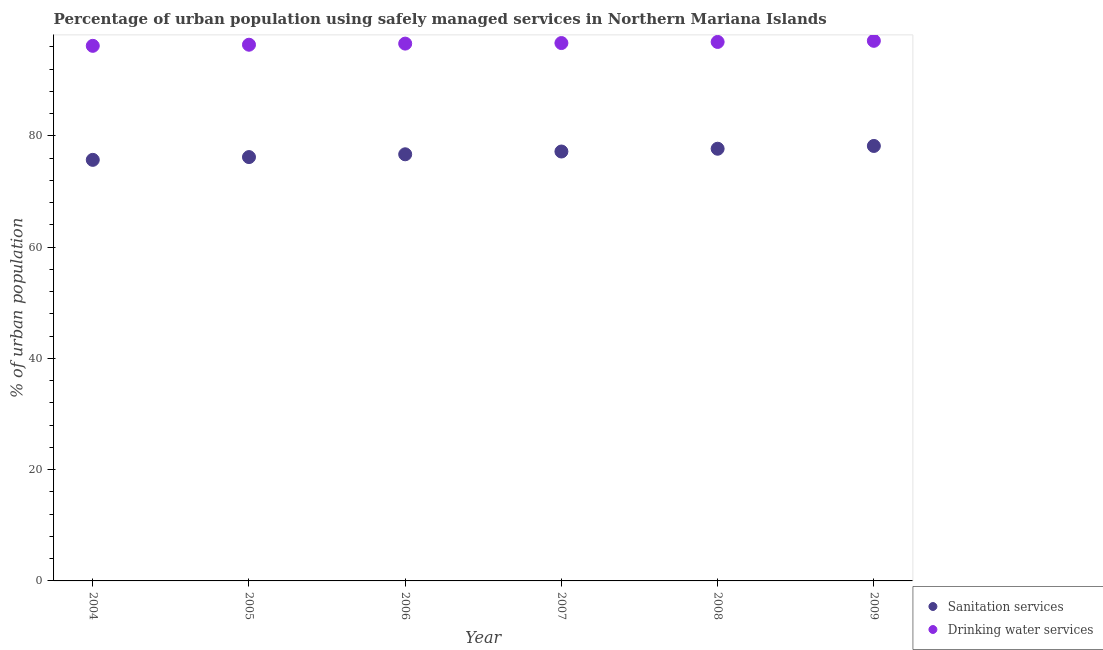What is the percentage of urban population who used sanitation services in 2009?
Offer a very short reply. 78.2. Across all years, what is the maximum percentage of urban population who used sanitation services?
Your response must be concise. 78.2. Across all years, what is the minimum percentage of urban population who used drinking water services?
Give a very brief answer. 96.2. In which year was the percentage of urban population who used sanitation services maximum?
Make the answer very short. 2009. In which year was the percentage of urban population who used drinking water services minimum?
Your answer should be very brief. 2004. What is the total percentage of urban population who used sanitation services in the graph?
Your response must be concise. 461.7. What is the average percentage of urban population who used drinking water services per year?
Provide a short and direct response. 96.65. In the year 2008, what is the difference between the percentage of urban population who used sanitation services and percentage of urban population who used drinking water services?
Provide a succinct answer. -19.2. What is the ratio of the percentage of urban population who used sanitation services in 2004 to that in 2006?
Your answer should be very brief. 0.99. What is the difference between the highest and the second highest percentage of urban population who used drinking water services?
Ensure brevity in your answer.  0.2. What is the difference between the highest and the lowest percentage of urban population who used drinking water services?
Keep it short and to the point. 0.9. Is the sum of the percentage of urban population who used drinking water services in 2005 and 2006 greater than the maximum percentage of urban population who used sanitation services across all years?
Your response must be concise. Yes. Does the percentage of urban population who used drinking water services monotonically increase over the years?
Your response must be concise. Yes. Is the percentage of urban population who used sanitation services strictly greater than the percentage of urban population who used drinking water services over the years?
Give a very brief answer. No. What is the difference between two consecutive major ticks on the Y-axis?
Provide a short and direct response. 20. Are the values on the major ticks of Y-axis written in scientific E-notation?
Provide a succinct answer. No. Does the graph contain any zero values?
Your answer should be very brief. No. Where does the legend appear in the graph?
Provide a short and direct response. Bottom right. How are the legend labels stacked?
Give a very brief answer. Vertical. What is the title of the graph?
Your response must be concise. Percentage of urban population using safely managed services in Northern Mariana Islands. What is the label or title of the X-axis?
Your response must be concise. Year. What is the label or title of the Y-axis?
Make the answer very short. % of urban population. What is the % of urban population of Sanitation services in 2004?
Make the answer very short. 75.7. What is the % of urban population of Drinking water services in 2004?
Provide a short and direct response. 96.2. What is the % of urban population of Sanitation services in 2005?
Offer a terse response. 76.2. What is the % of urban population in Drinking water services in 2005?
Keep it short and to the point. 96.4. What is the % of urban population in Sanitation services in 2006?
Your response must be concise. 76.7. What is the % of urban population of Drinking water services in 2006?
Your answer should be compact. 96.6. What is the % of urban population of Sanitation services in 2007?
Offer a terse response. 77.2. What is the % of urban population in Drinking water services in 2007?
Give a very brief answer. 96.7. What is the % of urban population of Sanitation services in 2008?
Provide a short and direct response. 77.7. What is the % of urban population in Drinking water services in 2008?
Provide a short and direct response. 96.9. What is the % of urban population of Sanitation services in 2009?
Make the answer very short. 78.2. What is the % of urban population of Drinking water services in 2009?
Provide a short and direct response. 97.1. Across all years, what is the maximum % of urban population of Sanitation services?
Provide a succinct answer. 78.2. Across all years, what is the maximum % of urban population of Drinking water services?
Your answer should be very brief. 97.1. Across all years, what is the minimum % of urban population in Sanitation services?
Keep it short and to the point. 75.7. Across all years, what is the minimum % of urban population in Drinking water services?
Your answer should be compact. 96.2. What is the total % of urban population in Sanitation services in the graph?
Ensure brevity in your answer.  461.7. What is the total % of urban population of Drinking water services in the graph?
Provide a short and direct response. 579.9. What is the difference between the % of urban population in Drinking water services in 2004 and that in 2005?
Provide a succinct answer. -0.2. What is the difference between the % of urban population in Sanitation services in 2004 and that in 2006?
Ensure brevity in your answer.  -1. What is the difference between the % of urban population of Drinking water services in 2004 and that in 2008?
Make the answer very short. -0.7. What is the difference between the % of urban population of Drinking water services in 2004 and that in 2009?
Offer a very short reply. -0.9. What is the difference between the % of urban population of Sanitation services in 2005 and that in 2006?
Provide a short and direct response. -0.5. What is the difference between the % of urban population in Drinking water services in 2005 and that in 2006?
Your answer should be very brief. -0.2. What is the difference between the % of urban population in Sanitation services in 2005 and that in 2009?
Keep it short and to the point. -2. What is the difference between the % of urban population of Drinking water services in 2005 and that in 2009?
Your response must be concise. -0.7. What is the difference between the % of urban population of Drinking water services in 2006 and that in 2007?
Your answer should be compact. -0.1. What is the difference between the % of urban population of Sanitation services in 2006 and that in 2008?
Provide a short and direct response. -1. What is the difference between the % of urban population of Drinking water services in 2006 and that in 2008?
Offer a terse response. -0.3. What is the difference between the % of urban population in Sanitation services in 2007 and that in 2008?
Keep it short and to the point. -0.5. What is the difference between the % of urban population in Drinking water services in 2007 and that in 2008?
Your answer should be very brief. -0.2. What is the difference between the % of urban population in Sanitation services in 2007 and that in 2009?
Your answer should be very brief. -1. What is the difference between the % of urban population of Drinking water services in 2008 and that in 2009?
Ensure brevity in your answer.  -0.2. What is the difference between the % of urban population in Sanitation services in 2004 and the % of urban population in Drinking water services in 2005?
Provide a succinct answer. -20.7. What is the difference between the % of urban population in Sanitation services in 2004 and the % of urban population in Drinking water services in 2006?
Provide a short and direct response. -20.9. What is the difference between the % of urban population in Sanitation services in 2004 and the % of urban population in Drinking water services in 2007?
Give a very brief answer. -21. What is the difference between the % of urban population in Sanitation services in 2004 and the % of urban population in Drinking water services in 2008?
Make the answer very short. -21.2. What is the difference between the % of urban population in Sanitation services in 2004 and the % of urban population in Drinking water services in 2009?
Give a very brief answer. -21.4. What is the difference between the % of urban population of Sanitation services in 2005 and the % of urban population of Drinking water services in 2006?
Your response must be concise. -20.4. What is the difference between the % of urban population in Sanitation services in 2005 and the % of urban population in Drinking water services in 2007?
Your answer should be compact. -20.5. What is the difference between the % of urban population of Sanitation services in 2005 and the % of urban population of Drinking water services in 2008?
Your response must be concise. -20.7. What is the difference between the % of urban population in Sanitation services in 2005 and the % of urban population in Drinking water services in 2009?
Provide a short and direct response. -20.9. What is the difference between the % of urban population of Sanitation services in 2006 and the % of urban population of Drinking water services in 2008?
Your response must be concise. -20.2. What is the difference between the % of urban population of Sanitation services in 2006 and the % of urban population of Drinking water services in 2009?
Give a very brief answer. -20.4. What is the difference between the % of urban population of Sanitation services in 2007 and the % of urban population of Drinking water services in 2008?
Ensure brevity in your answer.  -19.7. What is the difference between the % of urban population of Sanitation services in 2007 and the % of urban population of Drinking water services in 2009?
Ensure brevity in your answer.  -19.9. What is the difference between the % of urban population of Sanitation services in 2008 and the % of urban population of Drinking water services in 2009?
Offer a very short reply. -19.4. What is the average % of urban population of Sanitation services per year?
Offer a very short reply. 76.95. What is the average % of urban population of Drinking water services per year?
Offer a very short reply. 96.65. In the year 2004, what is the difference between the % of urban population in Sanitation services and % of urban population in Drinking water services?
Ensure brevity in your answer.  -20.5. In the year 2005, what is the difference between the % of urban population of Sanitation services and % of urban population of Drinking water services?
Make the answer very short. -20.2. In the year 2006, what is the difference between the % of urban population in Sanitation services and % of urban population in Drinking water services?
Your response must be concise. -19.9. In the year 2007, what is the difference between the % of urban population in Sanitation services and % of urban population in Drinking water services?
Keep it short and to the point. -19.5. In the year 2008, what is the difference between the % of urban population in Sanitation services and % of urban population in Drinking water services?
Your response must be concise. -19.2. In the year 2009, what is the difference between the % of urban population of Sanitation services and % of urban population of Drinking water services?
Keep it short and to the point. -18.9. What is the ratio of the % of urban population of Sanitation services in 2004 to that in 2007?
Provide a succinct answer. 0.98. What is the ratio of the % of urban population in Drinking water services in 2004 to that in 2007?
Make the answer very short. 0.99. What is the ratio of the % of urban population of Sanitation services in 2004 to that in 2008?
Your response must be concise. 0.97. What is the ratio of the % of urban population of Sanitation services in 2005 to that in 2006?
Your response must be concise. 0.99. What is the ratio of the % of urban population of Drinking water services in 2005 to that in 2006?
Your answer should be compact. 1. What is the ratio of the % of urban population of Sanitation services in 2005 to that in 2007?
Your answer should be compact. 0.99. What is the ratio of the % of urban population in Drinking water services in 2005 to that in 2007?
Offer a very short reply. 1. What is the ratio of the % of urban population in Sanitation services in 2005 to that in 2008?
Give a very brief answer. 0.98. What is the ratio of the % of urban population in Drinking water services in 2005 to that in 2008?
Provide a short and direct response. 0.99. What is the ratio of the % of urban population in Sanitation services in 2005 to that in 2009?
Your response must be concise. 0.97. What is the ratio of the % of urban population of Sanitation services in 2006 to that in 2007?
Your response must be concise. 0.99. What is the ratio of the % of urban population of Sanitation services in 2006 to that in 2008?
Ensure brevity in your answer.  0.99. What is the ratio of the % of urban population in Sanitation services in 2006 to that in 2009?
Offer a very short reply. 0.98. What is the ratio of the % of urban population of Sanitation services in 2007 to that in 2008?
Your response must be concise. 0.99. What is the ratio of the % of urban population in Sanitation services in 2007 to that in 2009?
Your answer should be very brief. 0.99. What is the ratio of the % of urban population in Drinking water services in 2007 to that in 2009?
Ensure brevity in your answer.  1. What is the ratio of the % of urban population in Drinking water services in 2008 to that in 2009?
Your answer should be very brief. 1. What is the difference between the highest and the second highest % of urban population in Sanitation services?
Offer a very short reply. 0.5. What is the difference between the highest and the lowest % of urban population in Sanitation services?
Give a very brief answer. 2.5. 